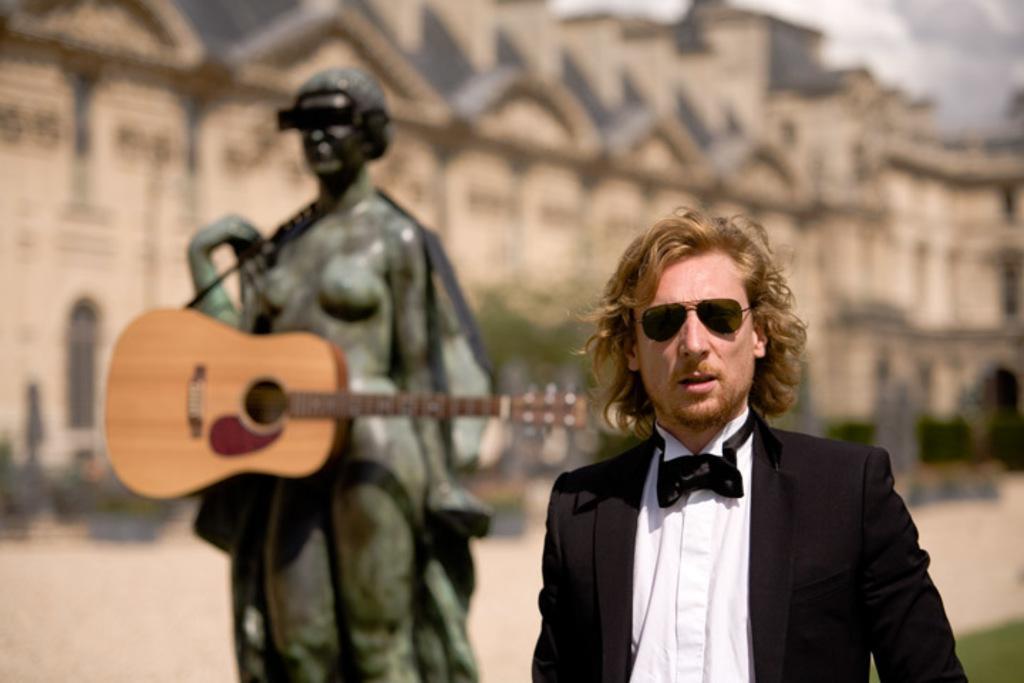Can you describe this image briefly? In this picture we can see a man wore blazer, goggle and beside to him a statue which is holding guitar and in background we can see building, trees and it is blur. 